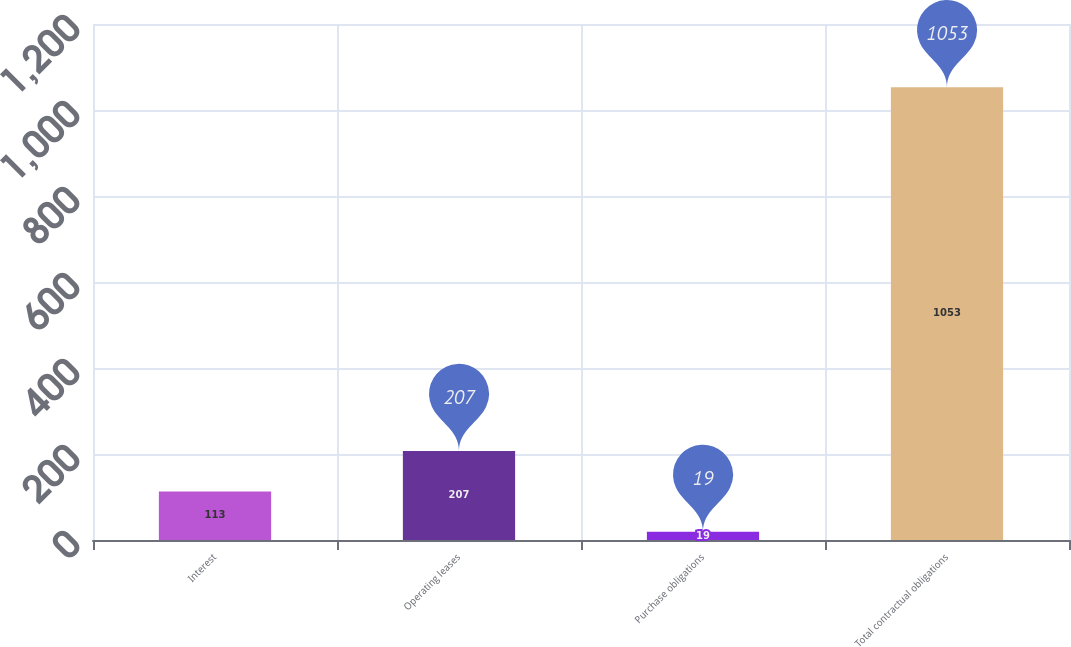Convert chart. <chart><loc_0><loc_0><loc_500><loc_500><bar_chart><fcel>Interest<fcel>Operating leases<fcel>Purchase obligations<fcel>Total contractual obligations<nl><fcel>113<fcel>207<fcel>19<fcel>1053<nl></chart> 